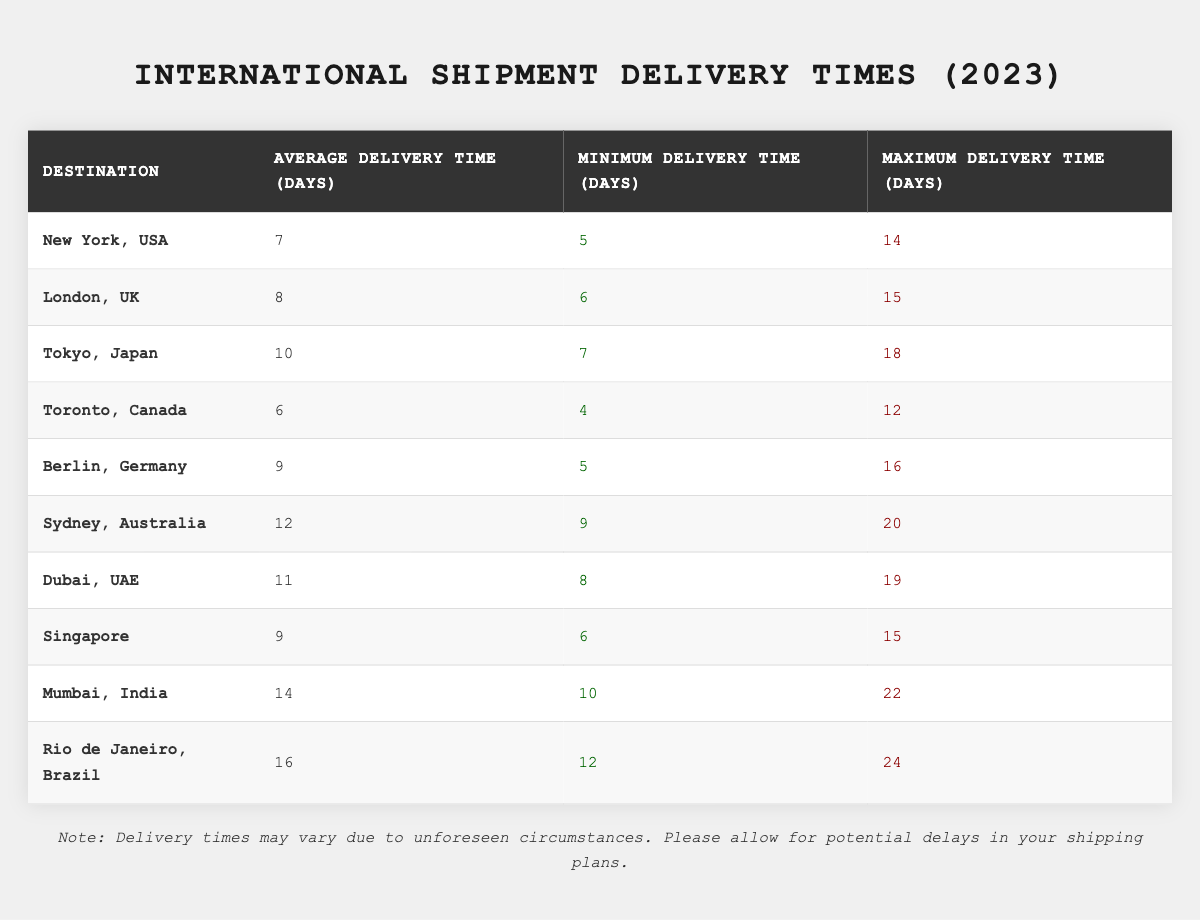What is the average delivery time to London, UK? The table shows that the average delivery time to London, UK is listed directly. It states "8 days" under the corresponding column for London.
Answer: 8 days Which destination has the longest maximum delivery time? By examining the "Maximum Delivery Time (Days)" column, Rio de Janeiro, Brazil has the highest value listed, which is 24 days.
Answer: Rio de Janeiro, Brazil What is the difference in average delivery time between New York, USA and Sydney, Australia? The average delivery time for New York is 7 days and for Sydney is 12 days. The difference is calculated as 12 - 7 = 5 days.
Answer: 5 days Is the minimum delivery time to Tokyo, Japan less than 8 days? The minimum delivery time to Tokyo is listed as 7 days, which is less than 8 days. Therefore, the answer is yes.
Answer: Yes What is the total of the average delivery times for Toronto, Canada and Berlin, Germany? The average delivery time for Toronto is 6 days and for Berlin is 9 days. The total is calculated as 6 + 9 = 15 days.
Answer: 15 days Which destination has the lowest minimum delivery time? By checking the "Minimum Delivery Time (Days)" column, Toronto, Canada has the lowest minimum delivery time listed as 4 days.
Answer: Toronto, Canada If you sum the average delivery times for all destinations, what is the total? The sum of the average delivery times is calculated as follows: 7 + 8 + 10 + 6 + 9 + 12 + 11 + 9 + 14 + 16 = 82 days.
Answer: 82 days Is the average delivery time to Dubai, UAE more than 10 days? The average delivery time to Dubai is listed as 11 days, which is indeed more than 10 days. Therefore, the answer is yes.
Answer: Yes What is the average minimum delivery time across all listed destinations? Adding all minimum delivery times: 5 + 6 + 7 + 4 + 5 + 9 + 8 + 6 + 10 + 12 = 72 days. Dividing by the number of destinations (10) gives an average of 72 / 10 = 7.2 days.
Answer: 7.2 days If the average delivery time to Mumbai, India is 14 days, does it exceed the average delivery time to Berlin, Germany? The average delivery time for Berlin is 9 days. Since 14 is greater than 9, it does exceed Berlin's average delivery time.
Answer: Yes 